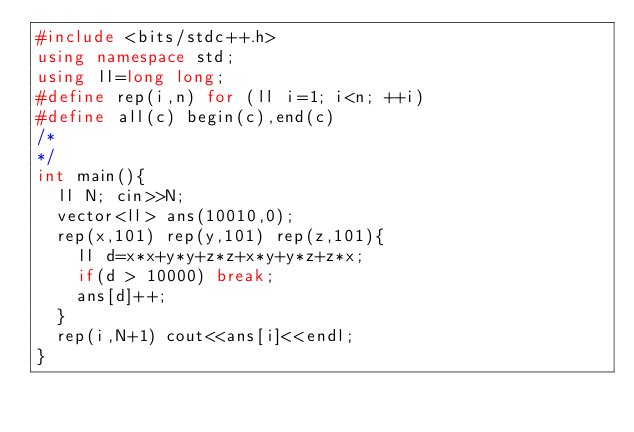<code> <loc_0><loc_0><loc_500><loc_500><_C++_>#include <bits/stdc++.h>
using namespace std;
using ll=long long;
#define rep(i,n) for (ll i=1; i<n; ++i)
#define all(c) begin(c),end(c)
/*
*/
int main(){
  ll N; cin>>N;
  vector<ll> ans(10010,0);
  rep(x,101) rep(y,101) rep(z,101){
    ll d=x*x+y*y+z*z+x*y+y*z+z*x;
    if(d > 10000) break;
    ans[d]++;
  }
  rep(i,N+1) cout<<ans[i]<<endl;
}</code> 